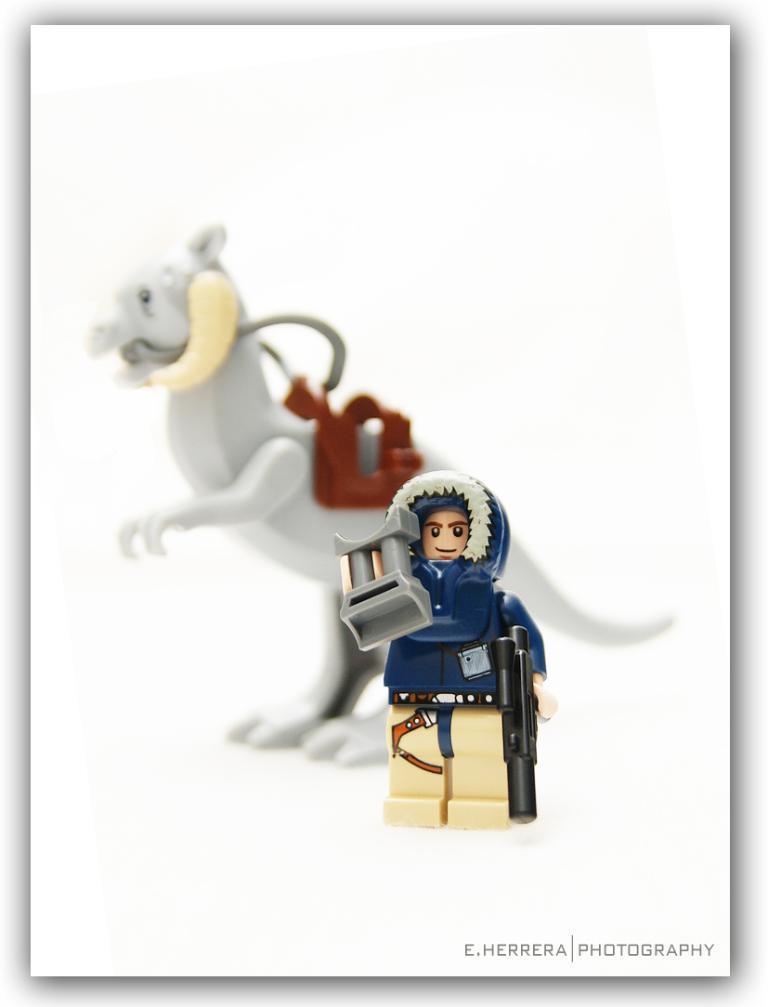Please provide a concise description of this image. This is an edited image. In this image we can see some toys placed on the surface. 